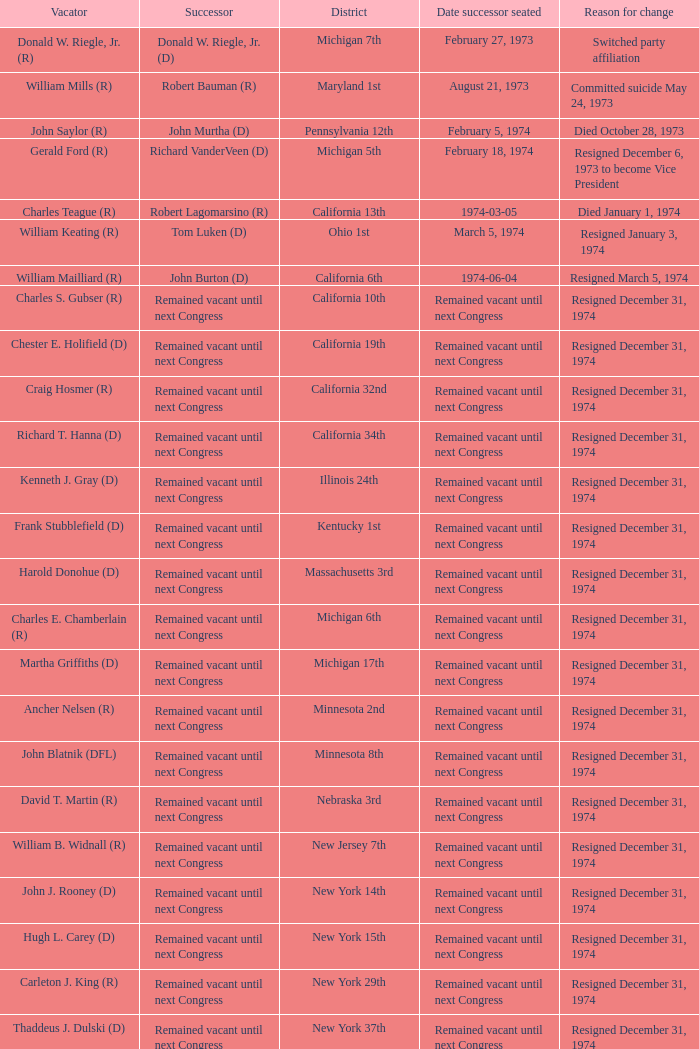Who was the vacator when the date successor seated was august 21, 1973? William Mills (R). 